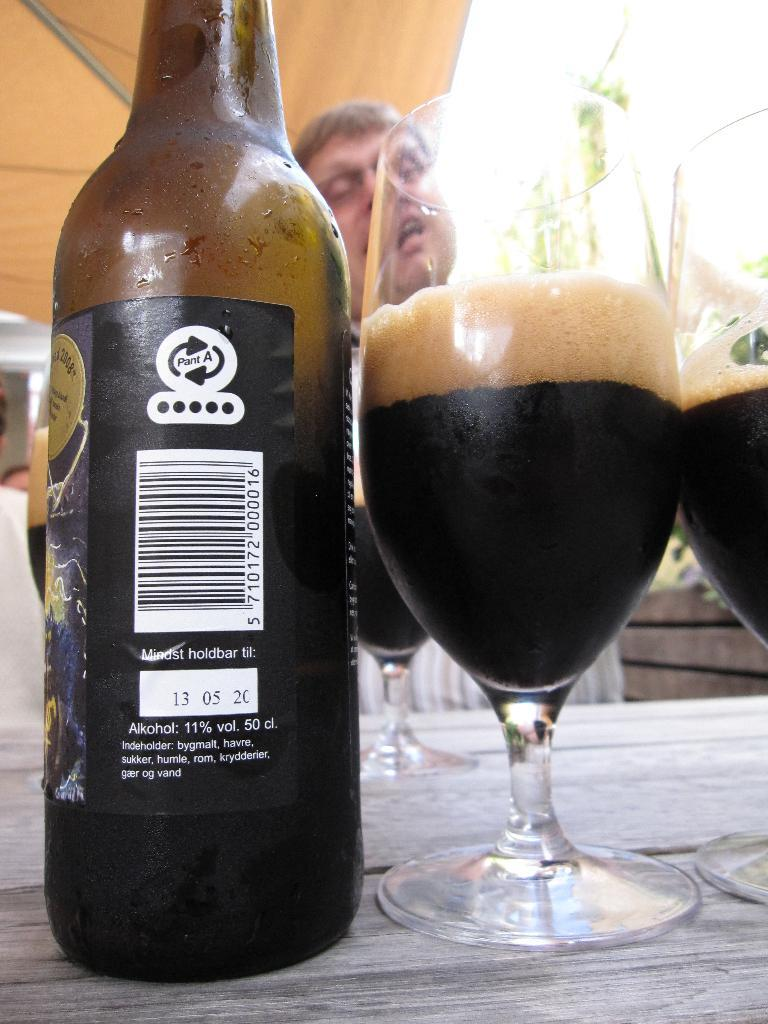What is present on the table in the image? There is a bottle and a glass on the table in the image. Can you describe the objects on the table? The objects on the table are a bottle and a glass. What is the purpose of the glass in the image? The glass is likely for drinking or holding a beverage. What is the purpose of the bottle in the image? The bottle may contain a beverage or liquid. What type of machine is depicted in the image? There is no machine present in the image; it only features a bottle and a glass on a table. How many clocks are visible in the image? There are no clocks present in the image. 